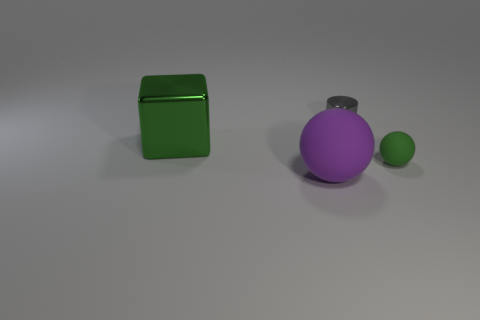Add 1 metallic blocks. How many objects exist? 5 Subtract all cylinders. How many objects are left? 3 Add 2 gray metallic cylinders. How many gray metallic cylinders exist? 3 Subtract 0 blue cylinders. How many objects are left? 4 Subtract all tiny shiny cylinders. Subtract all green blocks. How many objects are left? 2 Add 2 big cubes. How many big cubes are left? 3 